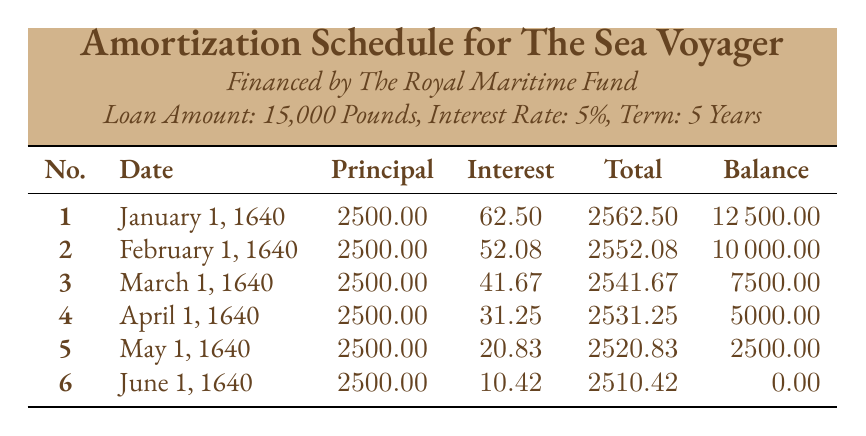What is the total amount paid in the first payment? The first payment consists of both principal and interest payments. From the table, the principal payment is 2500 and the interest payment is 62.50. Therefore, the total payment for the first month is 2500 + 62.50 = 2562.50.
Answer: 2562.50 What is the remaining balance after the second payment? After the second payment, the remaining balance indicated in the table is 10000. This value is explicitly stated under the "Balance" column for the second payment row.
Answer: 10000 Did the interest payment decrease with each subsequent payment? Yes, the interest payment decreased consistently with each payment. Looking at the interest amounts for all six payments, they diminish from 62.50 (first payment) down to 10.42 (sixth payment).
Answer: Yes How much total interest was paid by the end of the loan term? The total interest paid can be calculated by summing the interest payments from each row in the table. The individual interest payments are: 62.50, 52.08, 41.67, 31.25, 20.83, and 10.42. Adding these values gives a total interest of 62.50 + 52.08 + 41.67 + 31.25 + 20.83 + 10.42 = 218.75.
Answer: 218.75 What was the principal amount paid in the fourth payment? According to the table, the principal payment for the fourth payment is explicitly stated as 2500.
Answer: 2500 If the loan period were to extend by one year, how would the monthly payment change? Extending the loan period typically distributes the principal payments over a longer term while changing the total amount of interest paid. However, since this requires recalculation of monthly payments that are not present in the given data, one cannot determine an exact new monthly payment. The existing payments would all be lower if redistributed over more payments.
Answer: Cannot determine exact new payment 